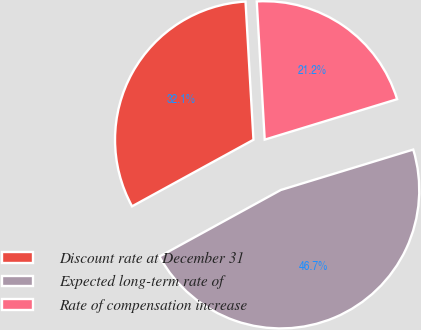<chart> <loc_0><loc_0><loc_500><loc_500><pie_chart><fcel>Discount rate at December 31<fcel>Expected long-term rate of<fcel>Rate of compensation increase<nl><fcel>32.07%<fcel>46.74%<fcel>21.2%<nl></chart> 